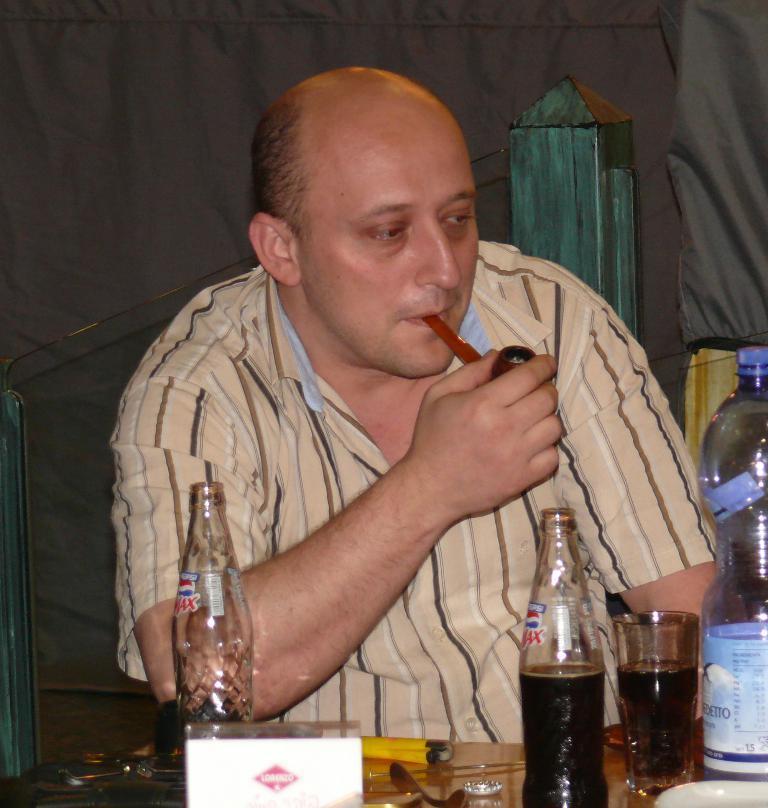In one or two sentences, can you explain what this image depicts? This man is sitting on a chair. In-front of this man there is a table, on a table there are bottles, glass. This man is holding a cigar. 